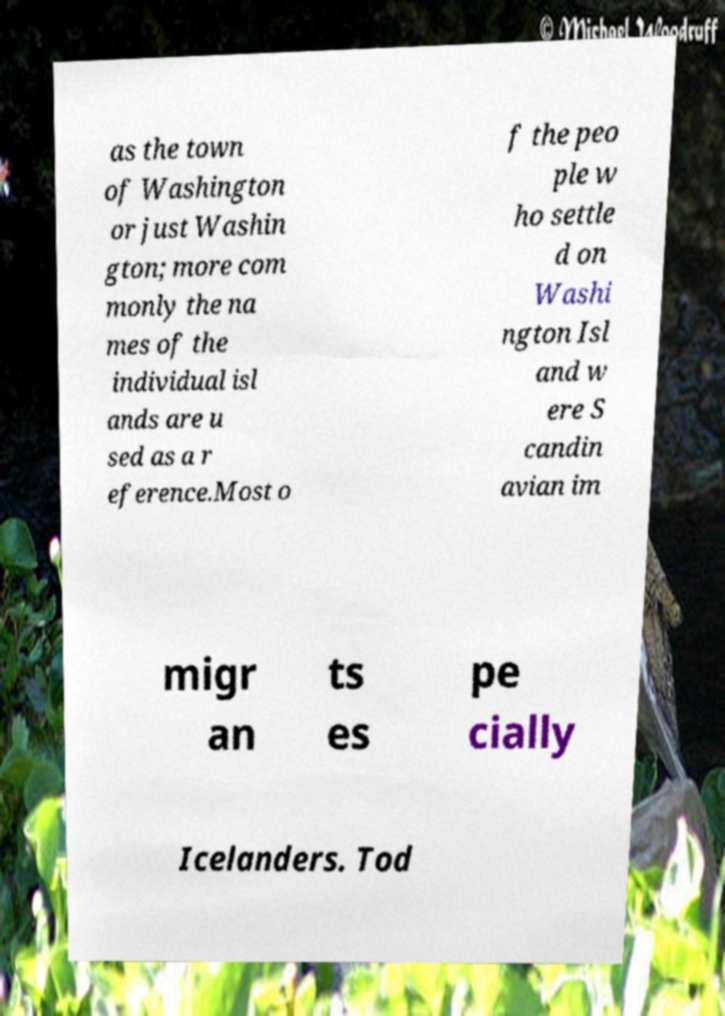I need the written content from this picture converted into text. Can you do that? as the town of Washington or just Washin gton; more com monly the na mes of the individual isl ands are u sed as a r eference.Most o f the peo ple w ho settle d on Washi ngton Isl and w ere S candin avian im migr an ts es pe cially Icelanders. Tod 